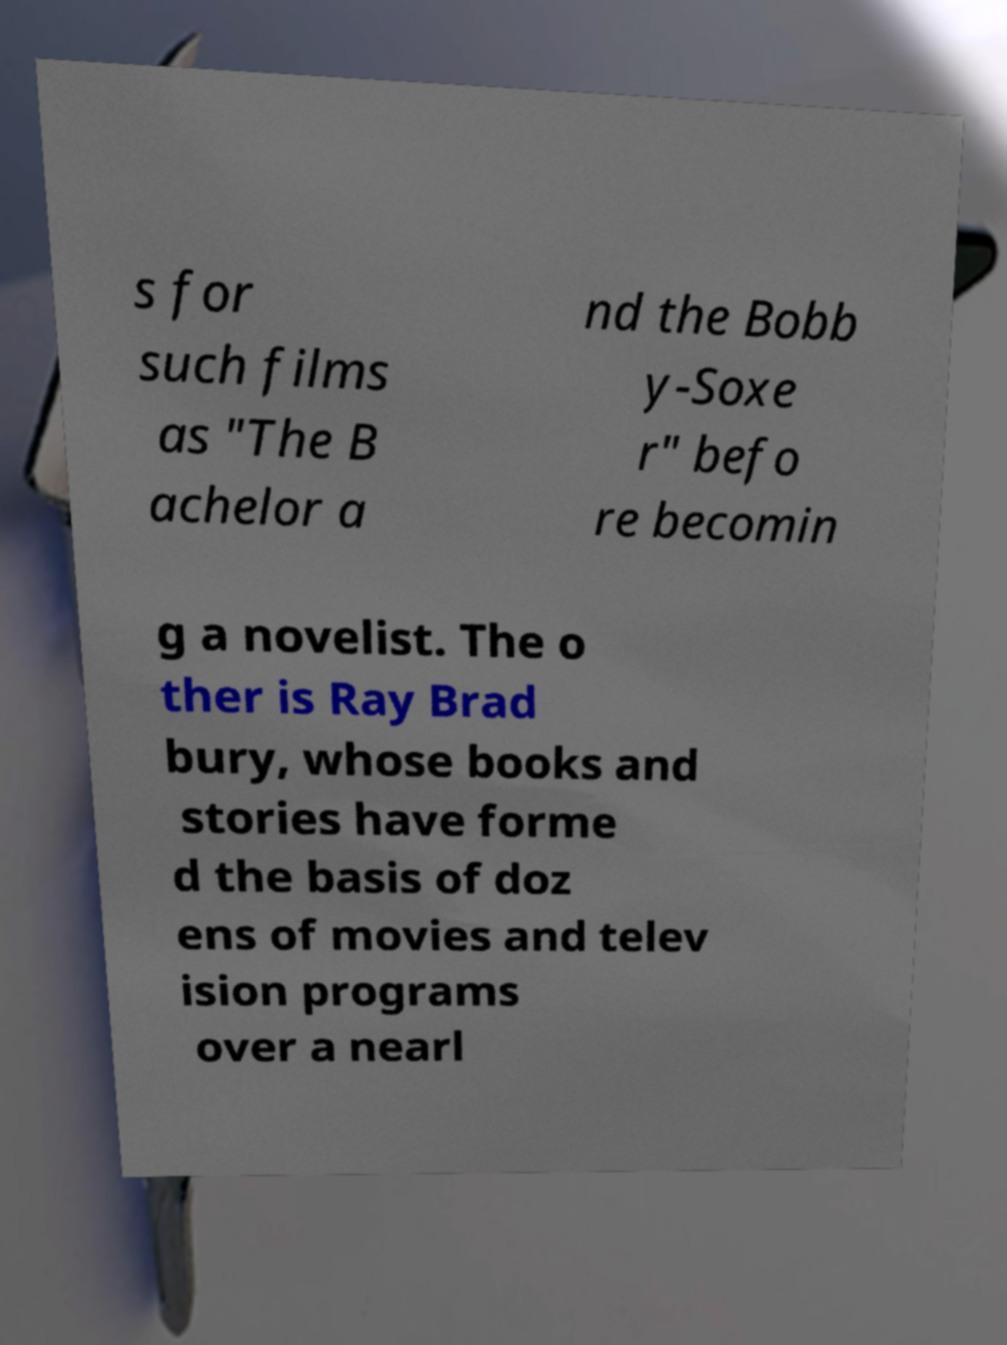Can you accurately transcribe the text from the provided image for me? s for such films as "The B achelor a nd the Bobb y-Soxe r" befo re becomin g a novelist. The o ther is Ray Brad bury, whose books and stories have forme d the basis of doz ens of movies and telev ision programs over a nearl 